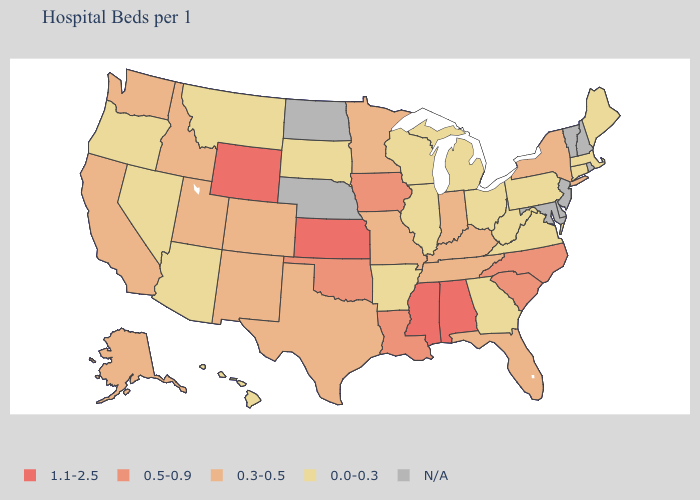Does Alaska have the lowest value in the USA?
Keep it brief. No. Name the states that have a value in the range 1.1-2.5?
Short answer required. Alabama, Kansas, Mississippi, Wyoming. Is the legend a continuous bar?
Quick response, please. No. Does the map have missing data?
Give a very brief answer. Yes. Does the map have missing data?
Quick response, please. Yes. Which states have the lowest value in the USA?
Give a very brief answer. Arizona, Arkansas, Connecticut, Georgia, Hawaii, Illinois, Maine, Massachusetts, Michigan, Montana, Nevada, Ohio, Oregon, Pennsylvania, South Dakota, Virginia, West Virginia, Wisconsin. What is the lowest value in the USA?
Answer briefly. 0.0-0.3. Name the states that have a value in the range 0.3-0.5?
Keep it brief. Alaska, California, Colorado, Florida, Idaho, Indiana, Kentucky, Minnesota, Missouri, New Mexico, New York, Tennessee, Texas, Utah, Washington. What is the value of Mississippi?
Quick response, please. 1.1-2.5. What is the value of Nebraska?
Write a very short answer. N/A. What is the value of Washington?
Answer briefly. 0.3-0.5. What is the value of Alaska?
Keep it brief. 0.3-0.5. What is the value of Minnesota?
Answer briefly. 0.3-0.5. Among the states that border Illinois , which have the highest value?
Answer briefly. Iowa. 